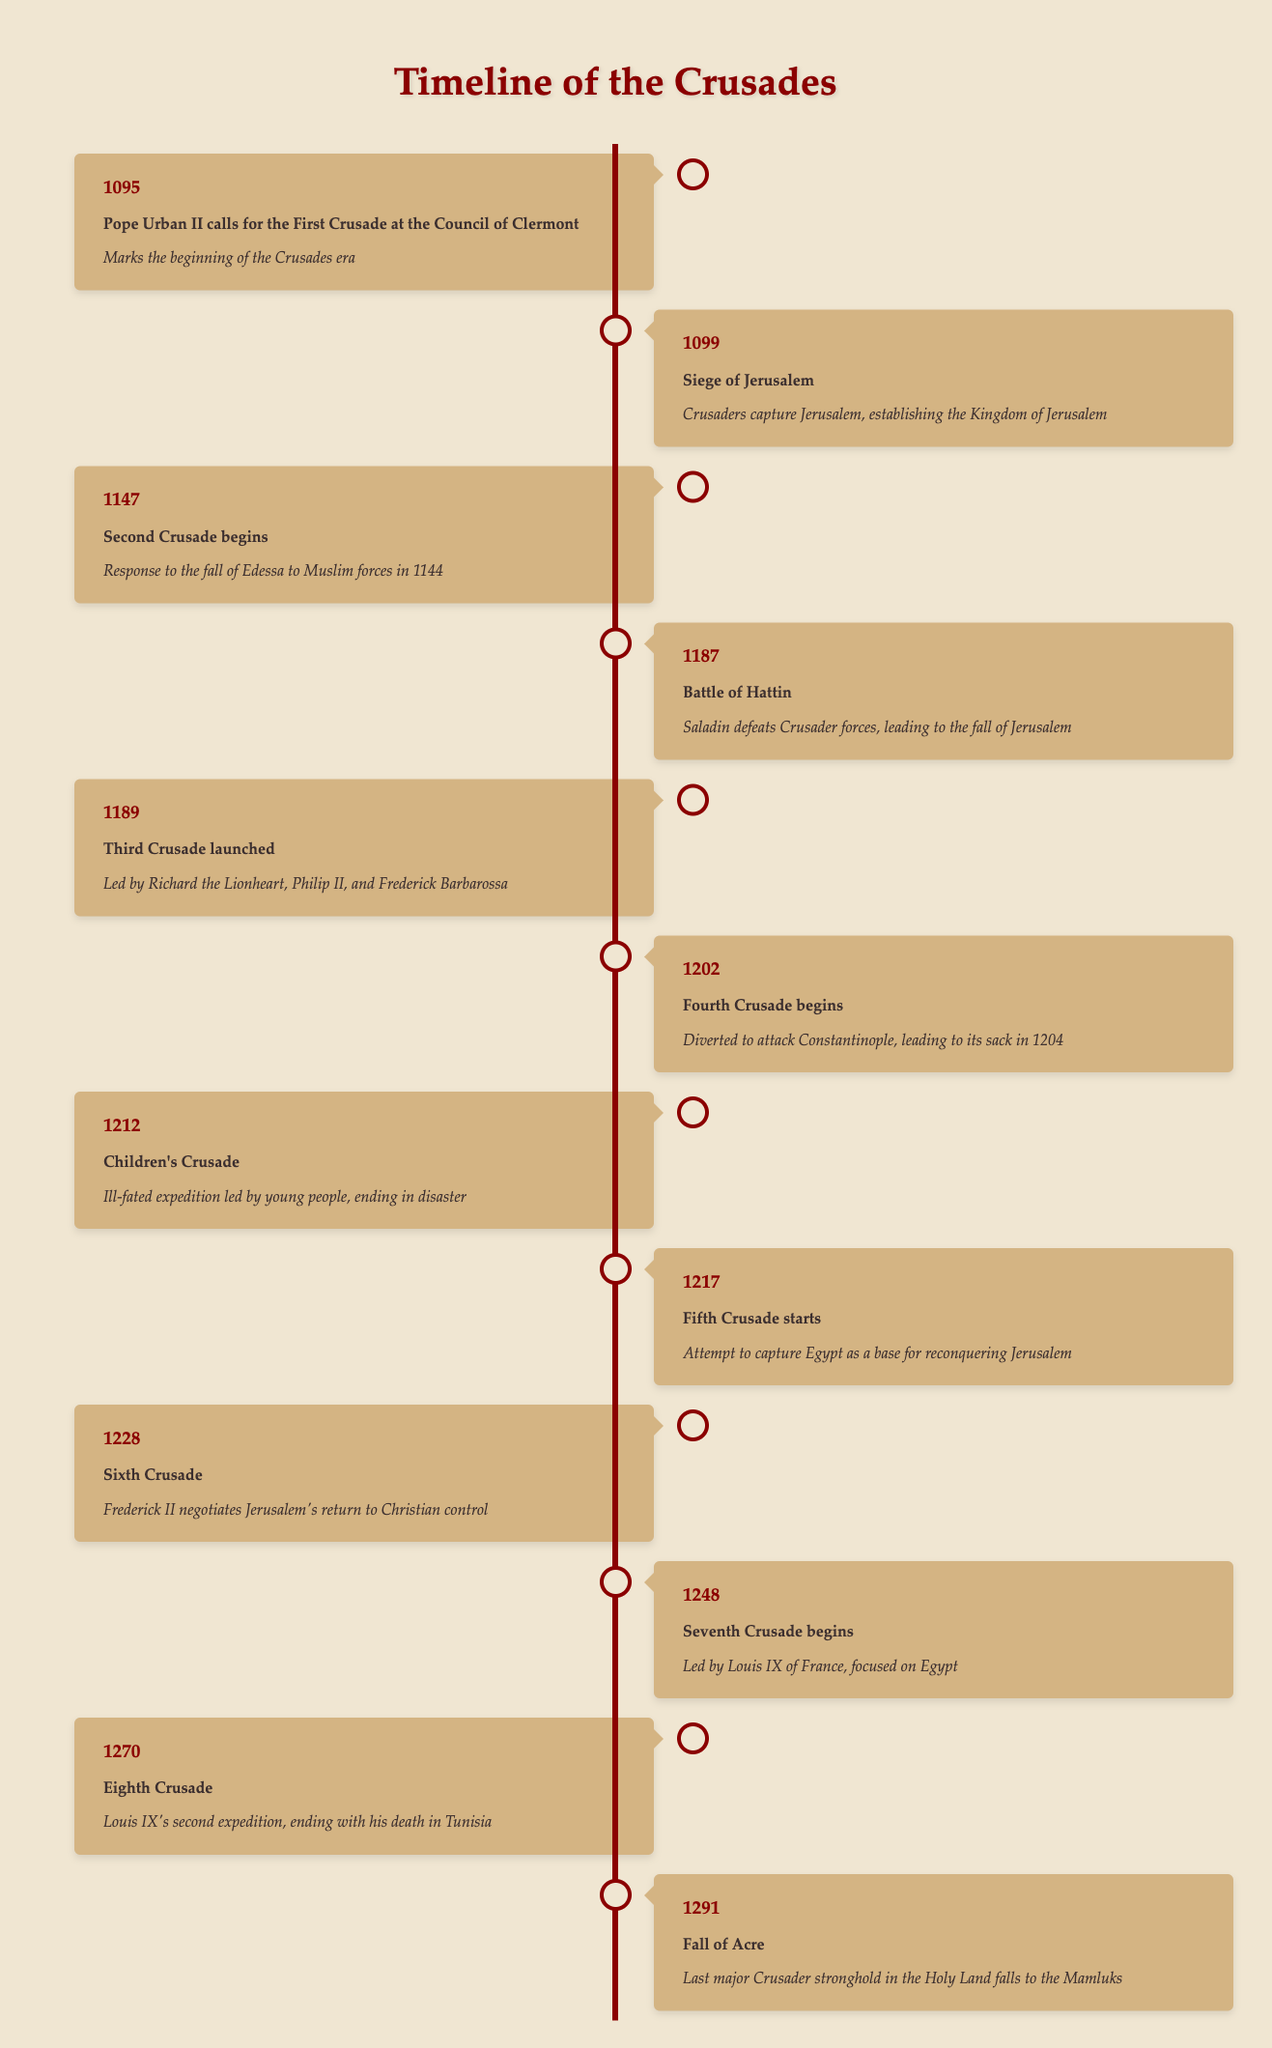What year did Pope Urban II call for the First Crusade? The table indicates that Pope Urban II called for the First Crusade in 1095. We can find this information in the row corresponding to that year.
Answer: 1095 What event took place in 1189? Referring to the table, the event that occurred in 1189 is the launch of the Third Crusade. This is stated in the corresponding row.
Answer: Third Crusade launched How many years passed between the Siege of Jerusalem and the Battle of Hattin? The Siege of Jerusalem occurred in 1099 and the Battle of Hattin took place in 1187. To find the number of years between these events, we subtract 1099 from 1187, which gives us 88 years.
Answer: 88 years Did the Children's Crusade end in success? Based on the significance listed in the table, the Children's Crusade is described as an ill-fated expedition that ended in disaster. This indicates that it did not end successfully.
Answer: No What was the main focus of the Seventh Crusade? The table states that the Seventh Crusade, which began in 1248, was led by Louis IX of France and focused on Egypt. This information can be found in the row corresponding to that year.
Answer: Focused on Egypt Which event marks the last major Crusader stronghold falling in the Holy Land? According to the table, the Fall of Acre in 1291 marks the last major Crusader stronghold in the Holy Land when it fell to the Mamluks. This is detailed in the last row.
Answer: Fall of Acre What was the significance of the Fourth Crusade? The significance of the Fourth Crusade, which began in 1202, is that it was diverted to attack Constantinople, ultimately leading to its sack in 1204. This information can be found in the corresponding row.
Answer: Attacked Constantinople, leading to its sack How many total Crusades are listed in the timeline? To determine the total number of Crusades listed, we can count the number of events provided in the timeline. There are 12 events, which refers to the number of Crusades mentioned.
Answer: 12 